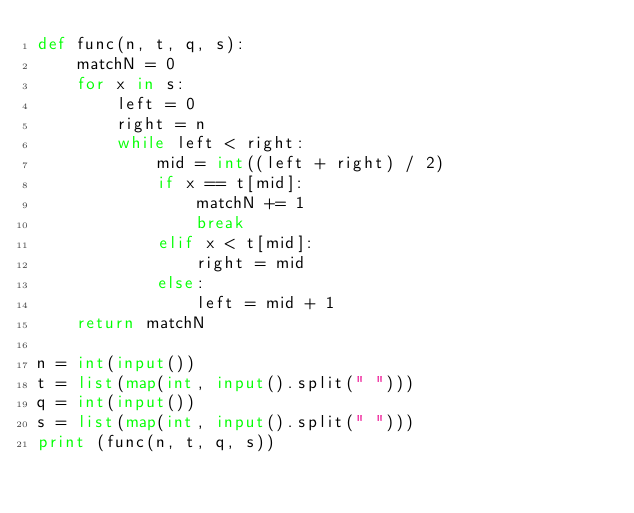Convert code to text. <code><loc_0><loc_0><loc_500><loc_500><_Python_>def func(n, t, q, s):
    matchN = 0
    for x in s:
        left = 0
        right = n
        while left < right:
            mid = int((left + right) / 2)
            if x == t[mid]:
                matchN += 1
                break
            elif x < t[mid]:
                right = mid
            else:
                left = mid + 1
    return matchN

n = int(input())
t = list(map(int, input().split(" ")))
q = int(input())
s = list(map(int, input().split(" ")))
print (func(n, t, q, s))
</code> 